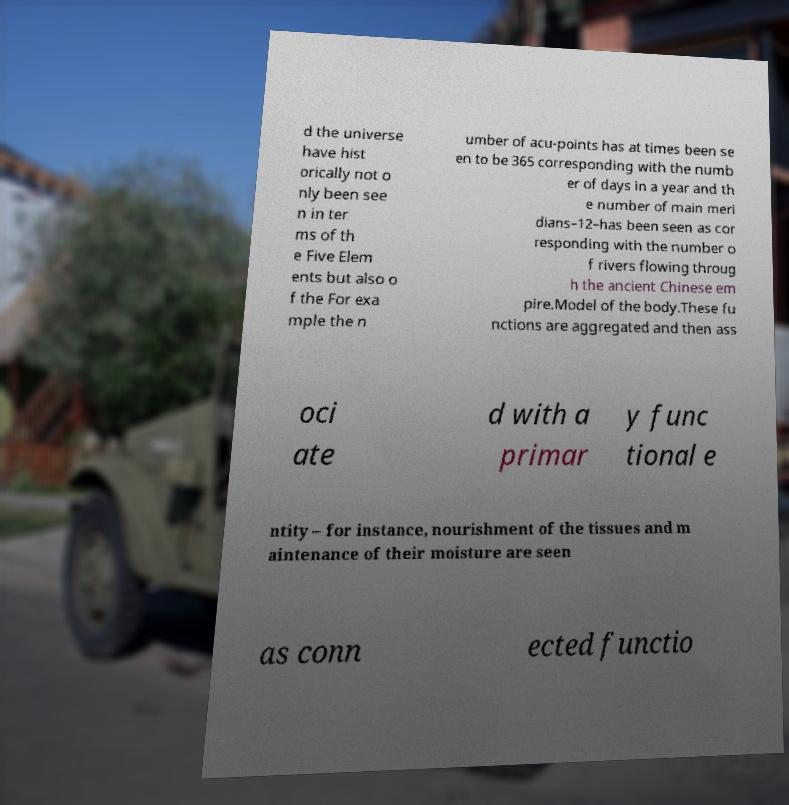Can you accurately transcribe the text from the provided image for me? d the universe have hist orically not o nly been see n in ter ms of th e Five Elem ents but also o f the For exa mple the n umber of acu-points has at times been se en to be 365 corresponding with the numb er of days in a year and th e number of main meri dians–12–has been seen as cor responding with the number o f rivers flowing throug h the ancient Chinese em pire.Model of the body.These fu nctions are aggregated and then ass oci ate d with a primar y func tional e ntity – for instance, nourishment of the tissues and m aintenance of their moisture are seen as conn ected functio 